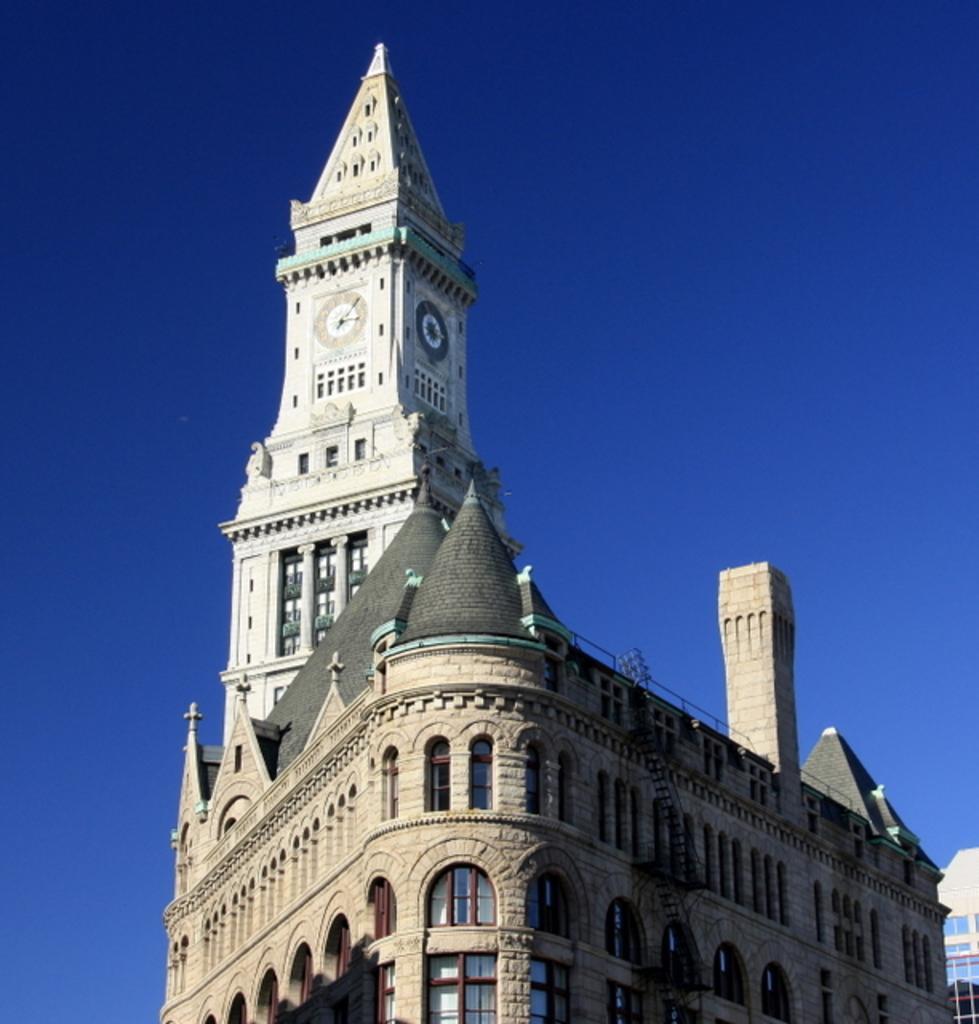How would you summarize this image in a sentence or two? In this picture I can observe a building. There is a clock tower on the building. In the background there is a sky. 